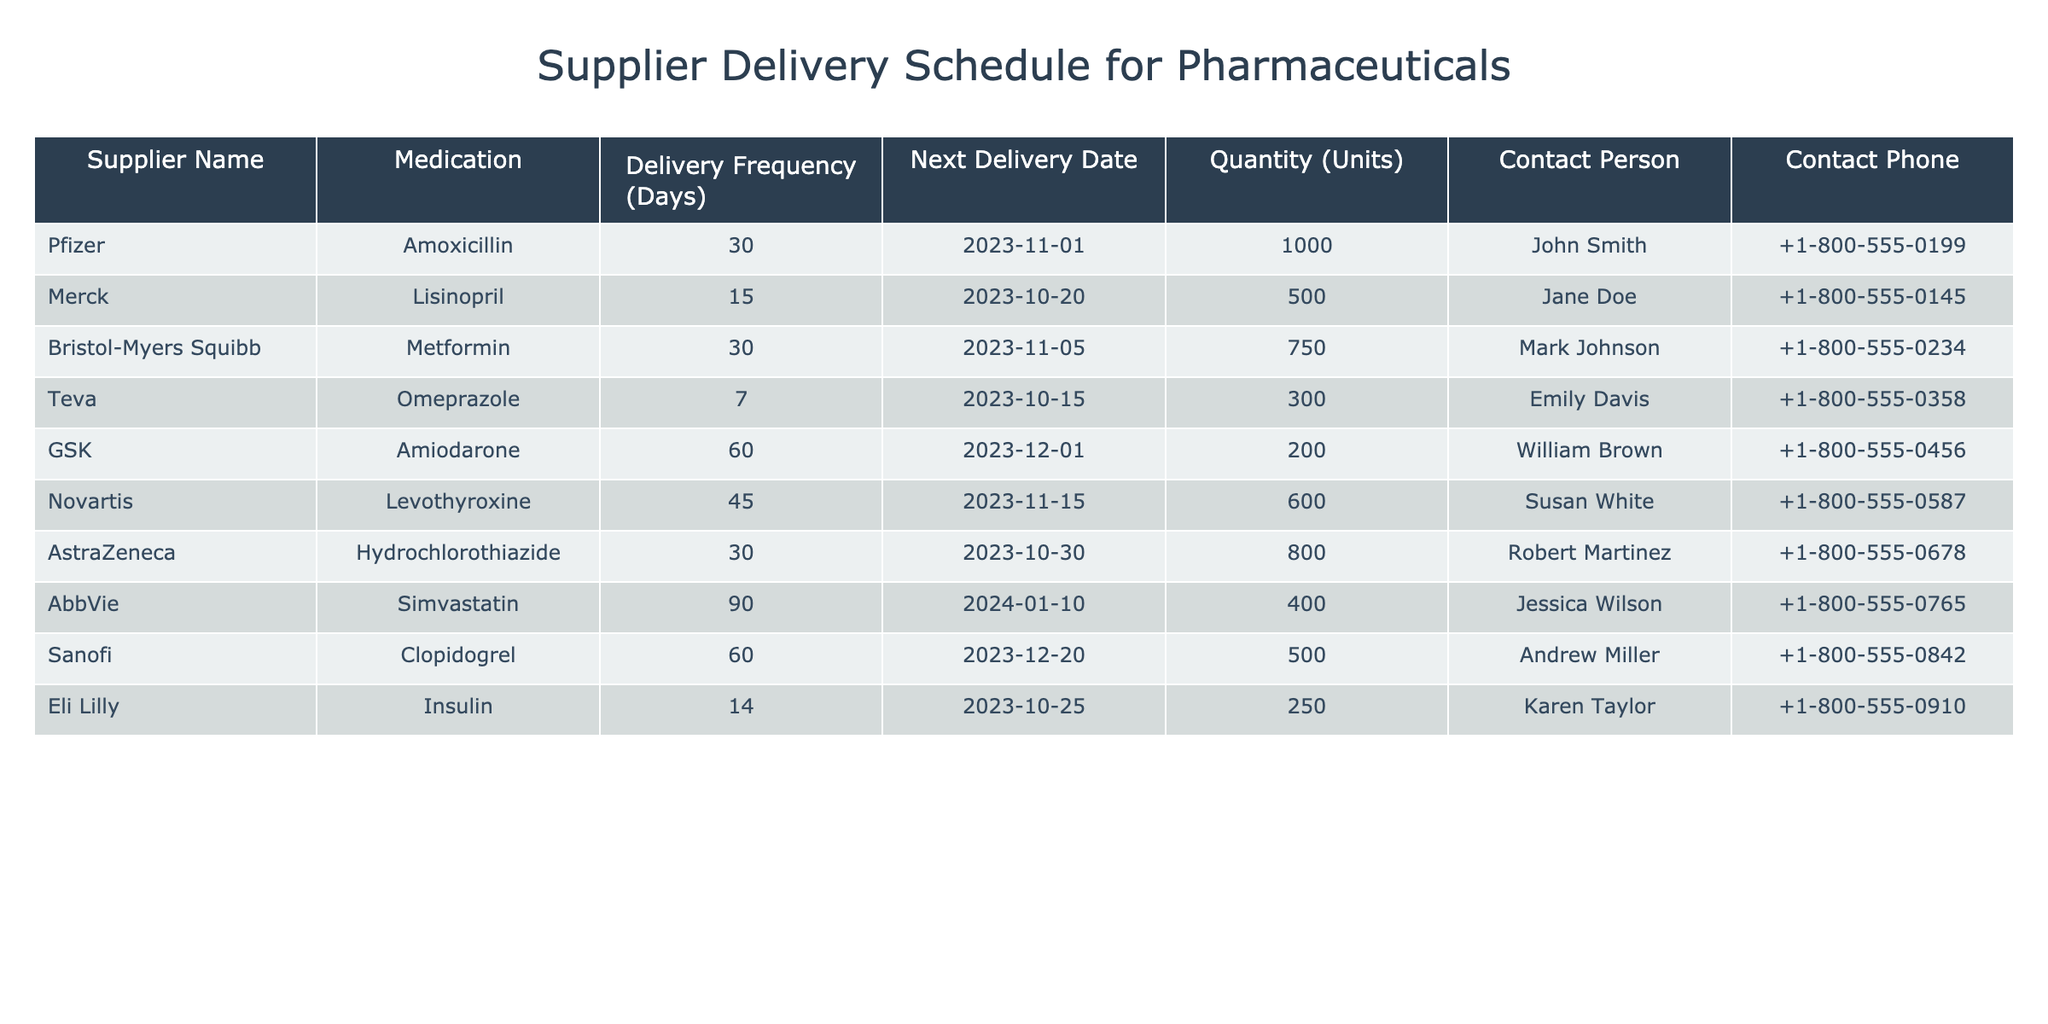What is the next delivery date for Omeprazole? The table shows that the next delivery date for Omeprazole, supplied by Teva, is listed under the 'Next Delivery Date' column, which indicates "2023-10-15".
Answer: 2023-10-15 How many units of Metformin will be delivered? Looking at the 'Quantity (Units)' column for Metformin, supplied by Bristol-Myers Squibb, the quantity specified is 750 units.
Answer: 750 Which medication has the longest delivery frequency in days? Observing the 'Delivery Frequency (Days)' column, Amiodarone and Simvastatin both have delivery frequencies of 60 and 90 days respectively. Since 90 is the highest, Simvastatin is identified as the medication with the longest delivery frequency.
Answer: Simvastatin Is there a medication supplied by Novartis? By scanning the 'Supplier Name' column, it can be confirmed that Novartis is listed as a supplier for Levothyroxine. Therefore, there is indeed a medication supplied by Novartis.
Answer: Yes What is the total quantity of units scheduled from suppliers with a delivery frequency of 30 days? First, identify the suppliers with a delivery frequency of 30 days: Amoxicillin (1000 units), Metformin (750 units), and Hydrochlorothiazide (800 units). Next, summing these quantities gives us 1000 + 750 + 800 = 2550. Thus, the total quantity is 2550 units.
Answer: 2550 When is the next delivery for Lisinopril? Checking the 'Next Delivery Date' for Lisinopril, supplied by Merck, it is indicated to be "2023-10-20".
Answer: 2023-10-20 How many suppliers deliver medication every 14 days? In the table, only one supplier, Eli Lilly, delivers medication (Insulin) every 14 days. Hence, the number of suppliers that deliver every 14 days is 1.
Answer: 1 Which medication will be delivered on 2023-11-15? To find out which medication will be delivered on this date, we look for it in the 'Next Delivery Date' column, and it shows that Levothyroxine, supplied by Novartis, is scheduled for delivery on this date.
Answer: Levothyroxine What is the average delivery frequency of all medications listed? First, gather all delivery frequencies: 30, 15, 30, 7, 60, 45, 30, 90, 60, 14. The total is 30 + 15 + 30 + 7 + 60 + 45 + 30 + 90 + 60 + 14 =  400. Next, divide this total by the number of medications (10) to get the average: 400 / 10 = 40. So, the average delivery frequency is 40 days.
Answer: 40 